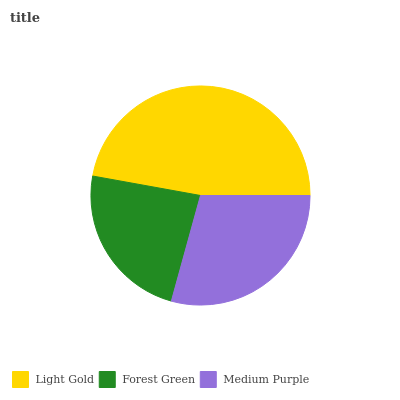Is Forest Green the minimum?
Answer yes or no. Yes. Is Light Gold the maximum?
Answer yes or no. Yes. Is Medium Purple the minimum?
Answer yes or no. No. Is Medium Purple the maximum?
Answer yes or no. No. Is Medium Purple greater than Forest Green?
Answer yes or no. Yes. Is Forest Green less than Medium Purple?
Answer yes or no. Yes. Is Forest Green greater than Medium Purple?
Answer yes or no. No. Is Medium Purple less than Forest Green?
Answer yes or no. No. Is Medium Purple the high median?
Answer yes or no. Yes. Is Medium Purple the low median?
Answer yes or no. Yes. Is Light Gold the high median?
Answer yes or no. No. Is Light Gold the low median?
Answer yes or no. No. 